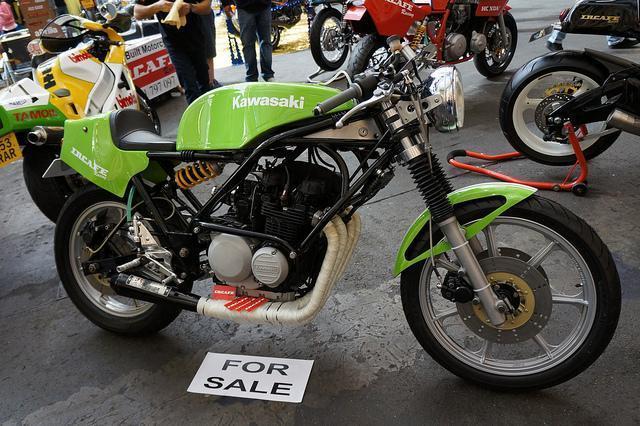How many people are there?
Give a very brief answer. 2. How many motorcycles are in the picture?
Give a very brief answer. 5. 